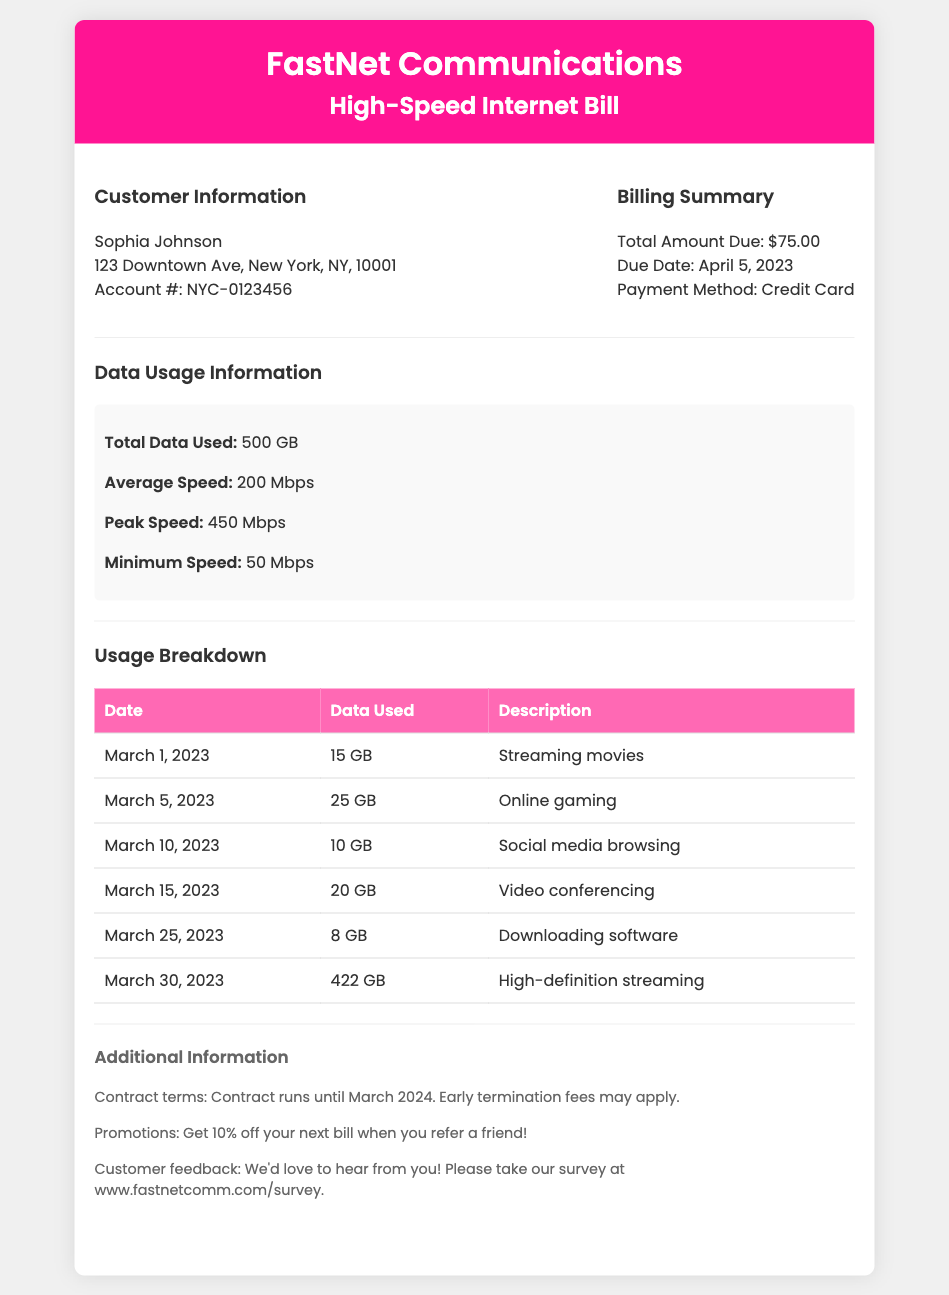what is the customer's name? The customer's name is presented in the Customer Information section of the document.
Answer: Sophia Johnson what is the total amount due? The total amount due is specified in the Billing Summary section of the document.
Answer: $75.00 what is the due date for the bill? The due date is mentioned directly in the Billing Summary section.
Answer: April 5, 2023 how much data was used on March 30, 2023? The data used for this date is listed in the Usage Breakdown table.
Answer: 422 GB what was the average speed during March 2023? The average speed is stated in the Data Usage Information section of the document.
Answer: 200 Mbps what type of activity used the most data? The highest data usage is shown in the Usage Breakdown table.
Answer: High-definition streaming what is the minimum speed recorded? The minimum speed is detailed in the Data Usage Information section.
Answer: 50 Mbps what promotion is currently available? The promotions available are discussed in the Additional Information section.
Answer: Get 10% off your next bill when you refer a friend! is there an early termination fee? The existence of early termination fees is mentioned in the Additional Information section regarding contract terms.
Answer: Yes 